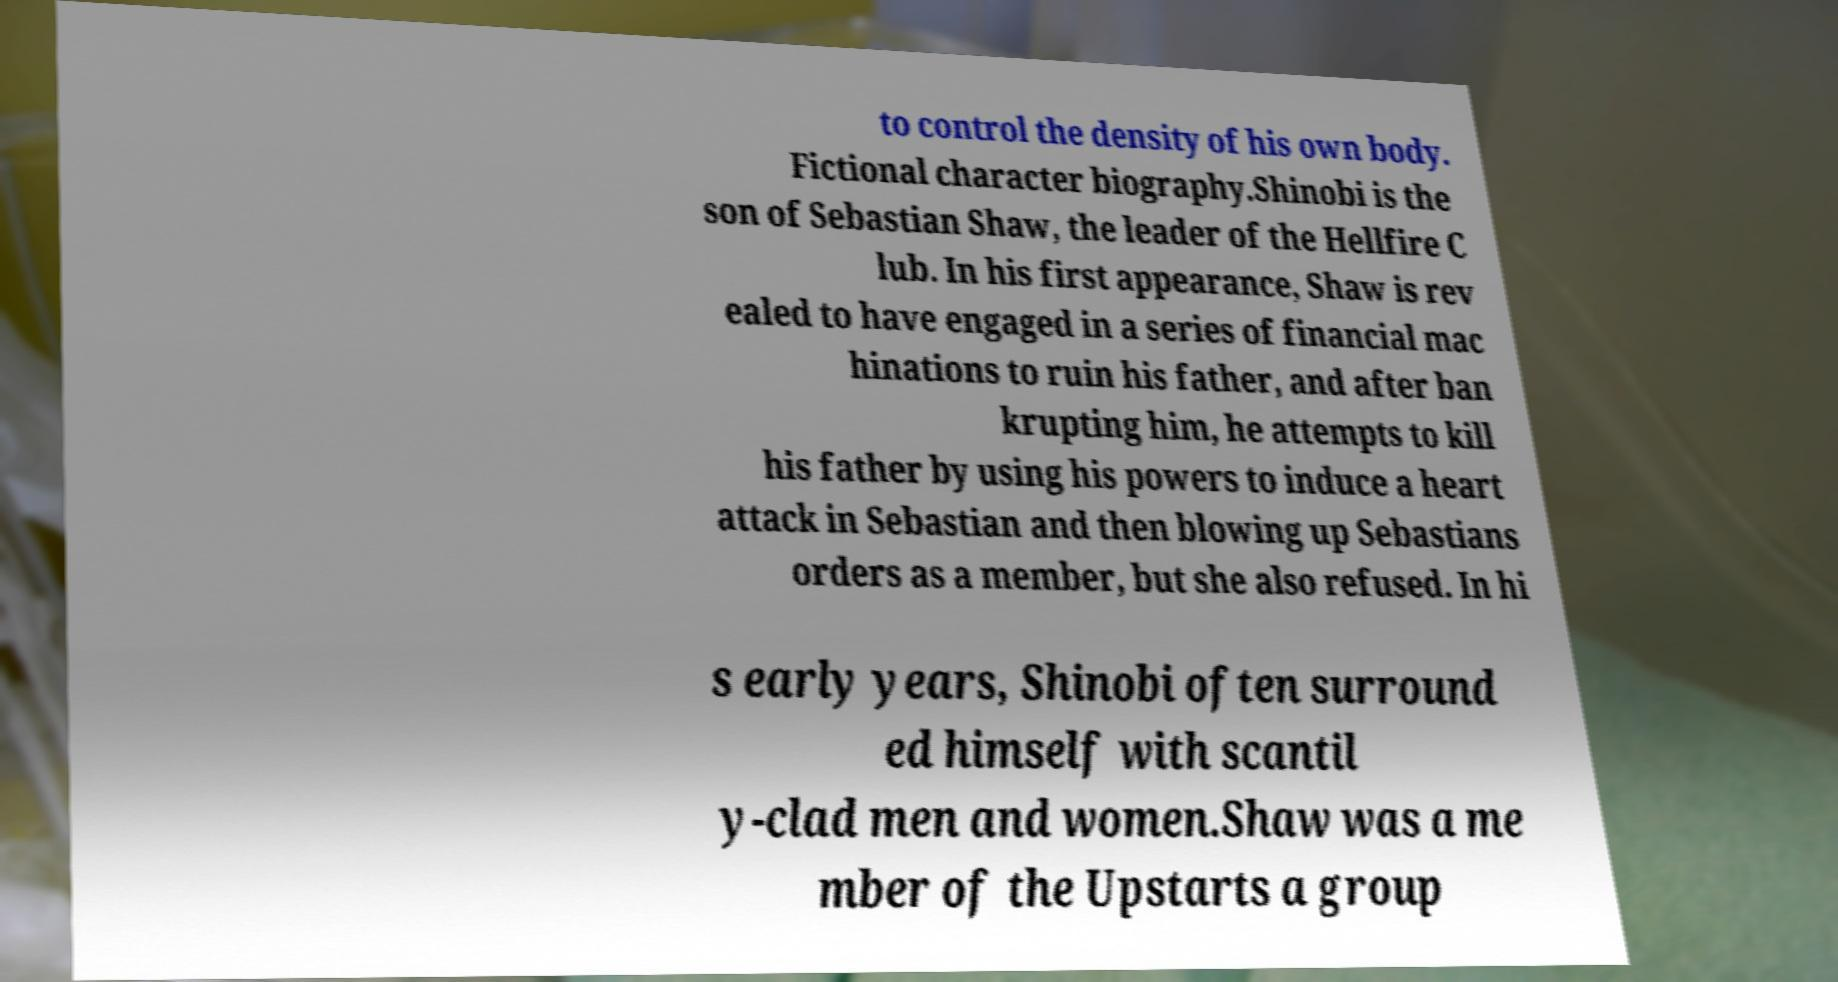I need the written content from this picture converted into text. Can you do that? to control the density of his own body. Fictional character biography.Shinobi is the son of Sebastian Shaw, the leader of the Hellfire C lub. In his first appearance, Shaw is rev ealed to have engaged in a series of financial mac hinations to ruin his father, and after ban krupting him, he attempts to kill his father by using his powers to induce a heart attack in Sebastian and then blowing up Sebastians orders as a member, but she also refused. In hi s early years, Shinobi often surround ed himself with scantil y-clad men and women.Shaw was a me mber of the Upstarts a group 